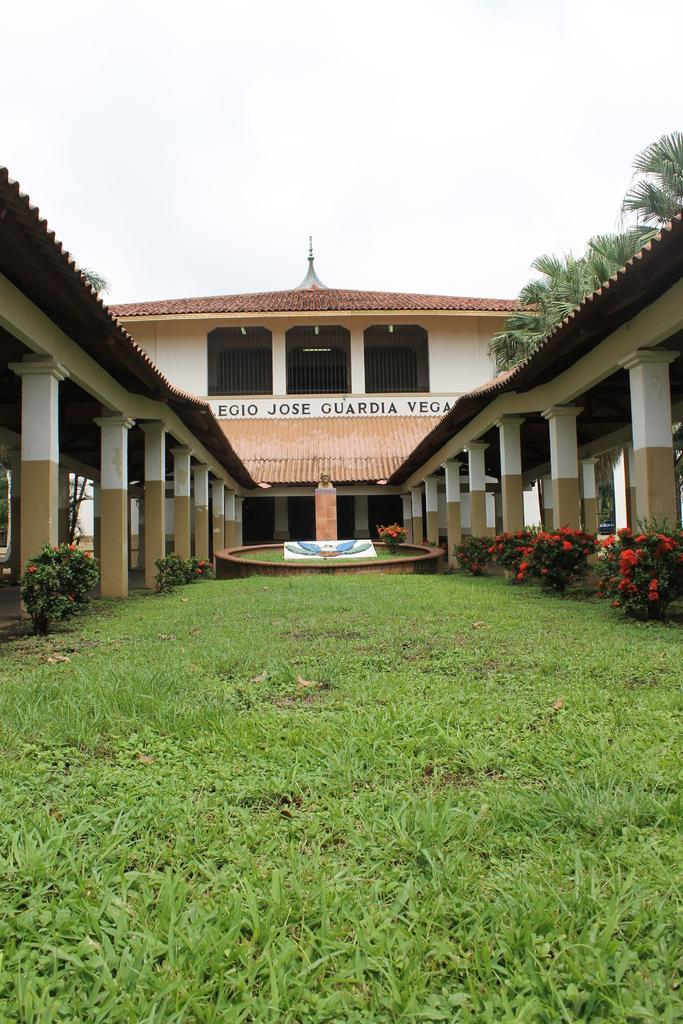What type of vegetation is present on the ground in the image? There is green grass on the ground in the image. What can be seen on the right side of the image? There are flower plants on the right side of the image. What architectural features are visible in the image? There are pillars in the image. What type of structure is present in the image? There is a building in the image. What is visible at the top of the image? The sky is visible at the top of the image. Can you see any ants carrying a pen in the image? There are no ants or pens present in the image. Is there a party happening in the building shown in the image? The image does not provide any information about a party or any activities happening inside the building. 